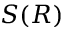Convert formula to latex. <formula><loc_0><loc_0><loc_500><loc_500>S ( R )</formula> 